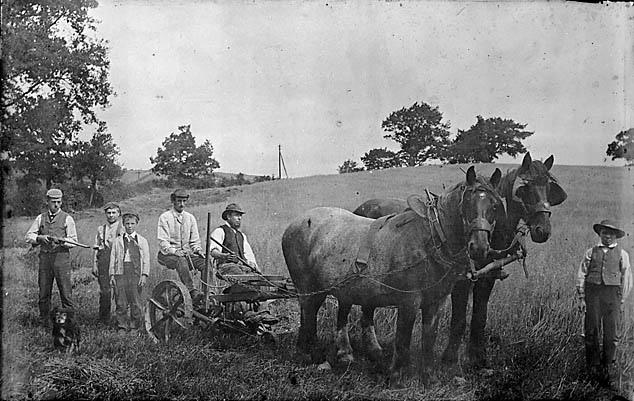How many wagon wheels are visible?
Answer briefly. 1. What do these animals produce?
Concise answer only. Nothing. How many horses?
Write a very short answer. 2. What color are the plants?
Write a very short answer. Green. How many animals are there?
Be succinct. 2. How can you tell this animal is in captivity?
Answer briefly. Reins. What animals are these?
Answer briefly. Horses. What animals are in the back?
Give a very brief answer. Horses. What is the man's job?
Answer briefly. Farmer. Do these animals have horns?
Give a very brief answer. No. What is the common name for the tree in this picture?
Short answer required. Oak. Is this a modern farming operation?
Write a very short answer. No. Is one person holding a gun?
Keep it brief. Yes. What color is the horse?
Be succinct. Brown. Are the animals facing the camera?
Write a very short answer. Yes. 